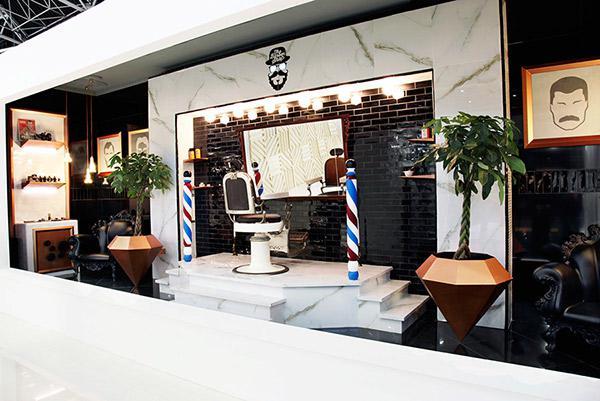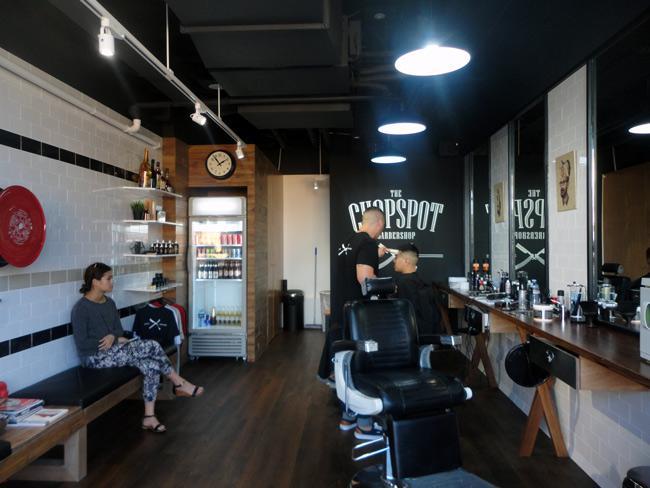The first image is the image on the left, the second image is the image on the right. Examine the images to the left and right. Is the description "Round mirrors in white frames are suspended in front of dark armchairs from black metal bars, in one image." accurate? Answer yes or no. No. The first image is the image on the left, the second image is the image on the right. For the images displayed, is the sentence "In at least one image there is a row of three white circles over a glass nail tables." factually correct? Answer yes or no. No. 